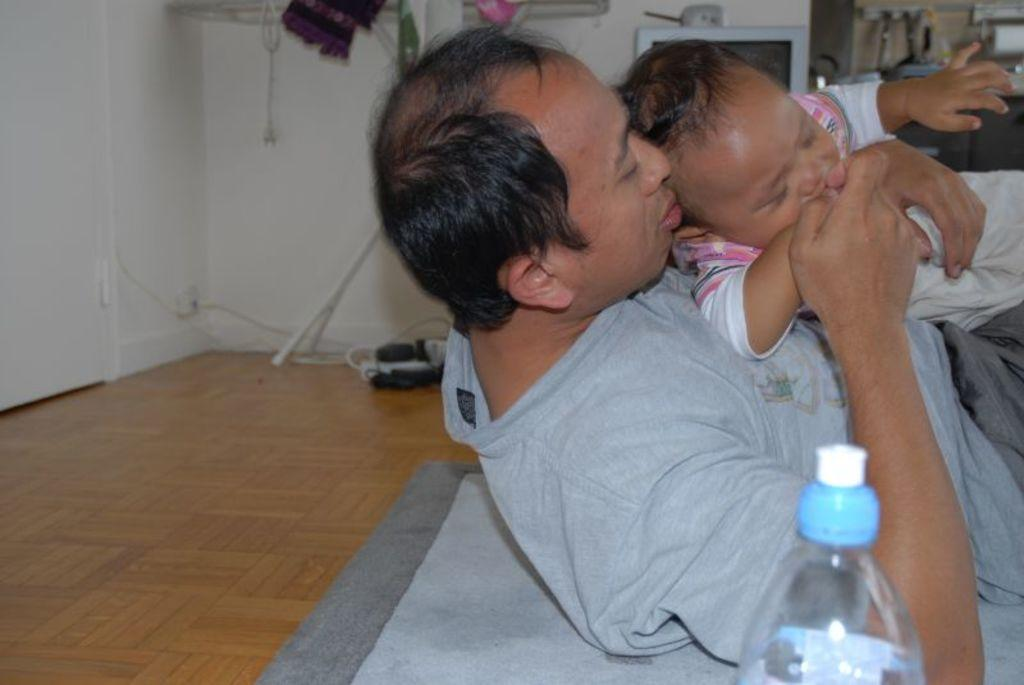What is the color of the wall in the image? The wall in the image is white. What are the two people on the floor doing? The two people are laying on the floor. What object can be seen in the front of the image? There is a bottle in the front of the image. Where is the nest located in the image? There is no nest present in the image. What part of the body is rubbing against the floor in the image? There is no indication in the image of any body part rubbing against the floor. 